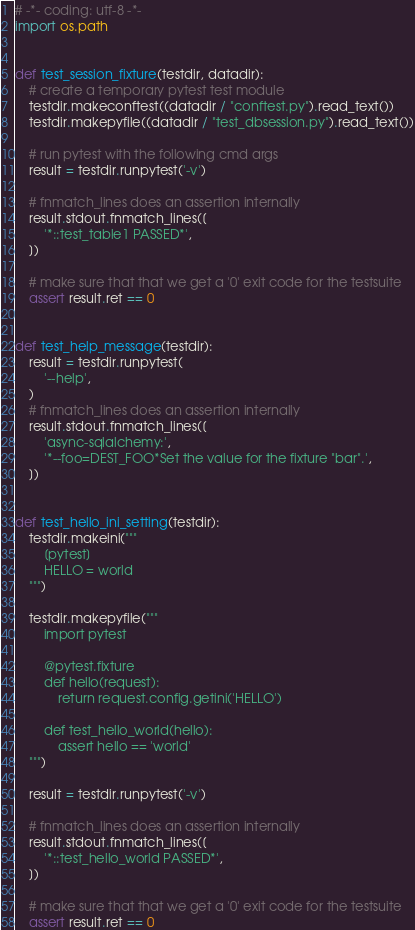Convert code to text. <code><loc_0><loc_0><loc_500><loc_500><_Python_># -*- coding: utf-8 -*-
import os.path


def test_session_fixture(testdir, datadir):
    # create a temporary pytest test module
    testdir.makeconftest((datadir / "conftest.py").read_text())
    testdir.makepyfile((datadir / "test_dbsession.py").read_text())

    # run pytest with the following cmd args
    result = testdir.runpytest('-v')

    # fnmatch_lines does an assertion internally
    result.stdout.fnmatch_lines([
        '*::test_table1 PASSED*',
    ])

    # make sure that that we get a '0' exit code for the testsuite
    assert result.ret == 0


def test_help_message(testdir):
    result = testdir.runpytest(
        '--help',
    )
    # fnmatch_lines does an assertion internally
    result.stdout.fnmatch_lines([
        'async-sqlalchemy:',
        '*--foo=DEST_FOO*Set the value for the fixture "bar".',
    ])


def test_hello_ini_setting(testdir):
    testdir.makeini("""
        [pytest]
        HELLO = world
    """)

    testdir.makepyfile("""
        import pytest

        @pytest.fixture
        def hello(request):
            return request.config.getini('HELLO')

        def test_hello_world(hello):
            assert hello == 'world'
    """)

    result = testdir.runpytest('-v')

    # fnmatch_lines does an assertion internally
    result.stdout.fnmatch_lines([
        '*::test_hello_world PASSED*',
    ])

    # make sure that that we get a '0' exit code for the testsuite
    assert result.ret == 0
</code> 